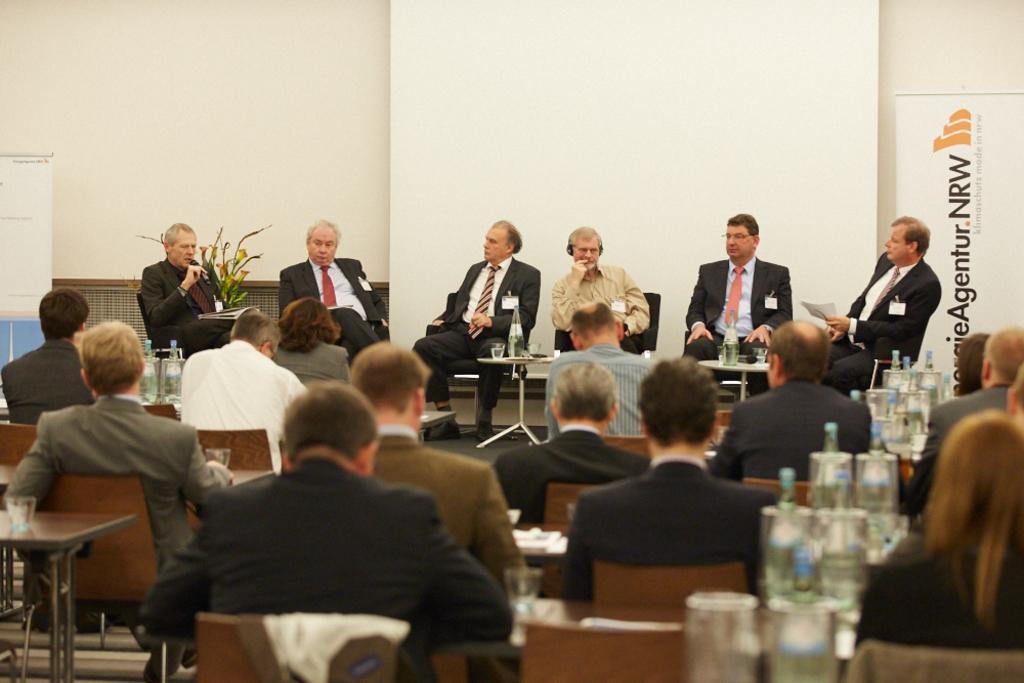Could you give a brief overview of what you see in this image? This picture is clicked in a conference hall. Here, we see many people sitting on chairs. On table, we see many glass and glass bottles. Behind these people, we see a white wall on which a white board with some text is placed. On the left corner of the picture, we see a white board. 